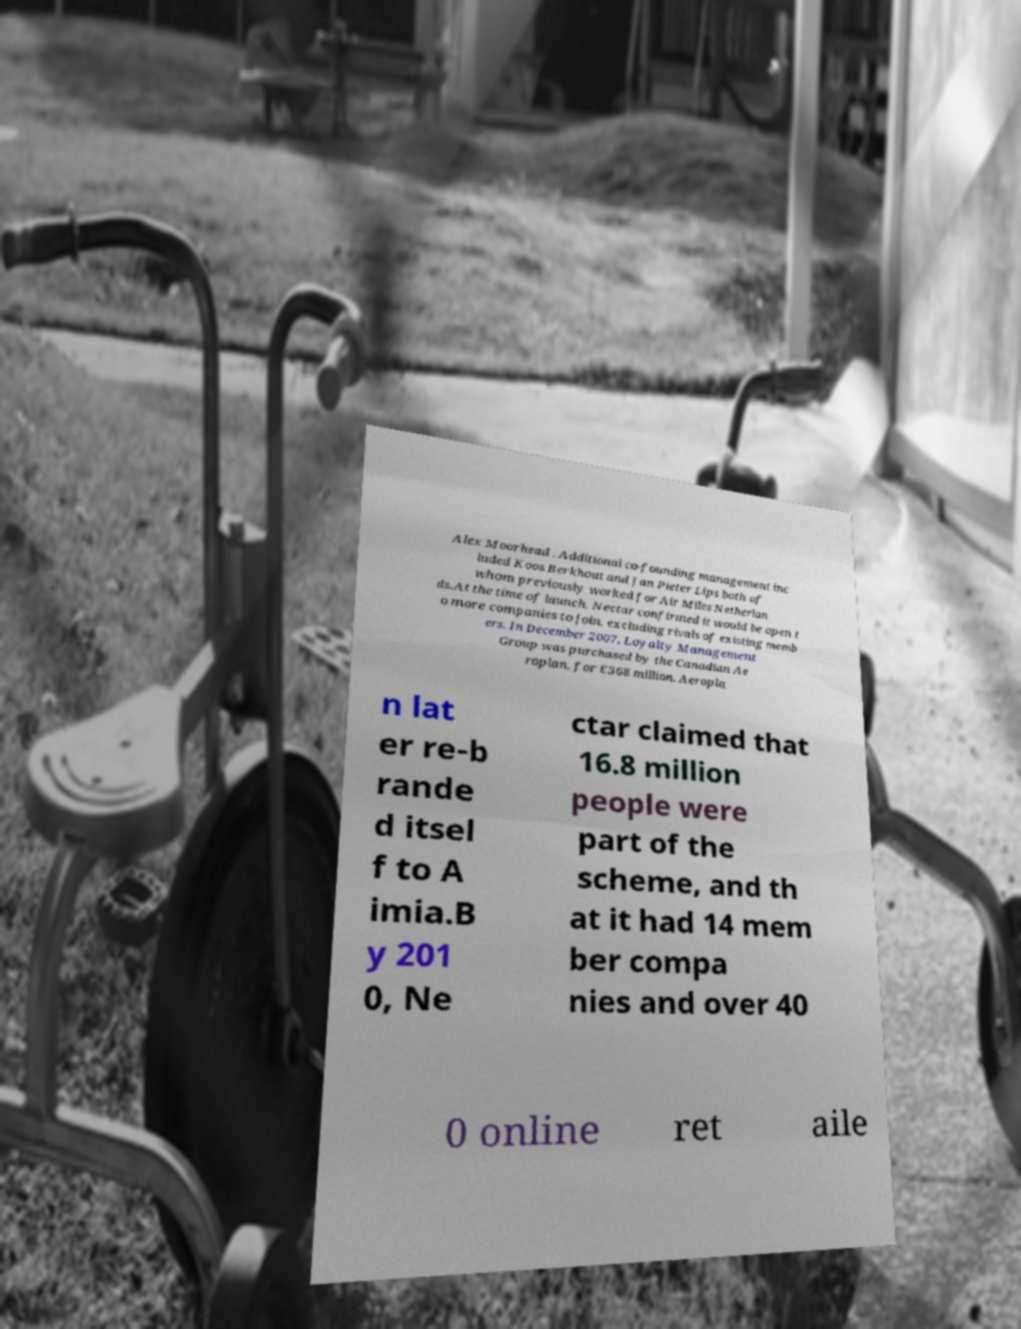Could you extract and type out the text from this image? Alex Moorhead . Additional co-founding management inc luded Koos Berkhout and Jan Pieter Lips both of whom previously worked for Air Miles Netherlan ds.At the time of launch, Nectar confirmed it would be open t o more companies to join, excluding rivals of existing memb ers. In December 2007, Loyalty Management Group was purchased by the Canadian Ae roplan, for £368 million. Aeropla n lat er re-b rande d itsel f to A imia.B y 201 0, Ne ctar claimed that 16.8 million people were part of the scheme, and th at it had 14 mem ber compa nies and over 40 0 online ret aile 